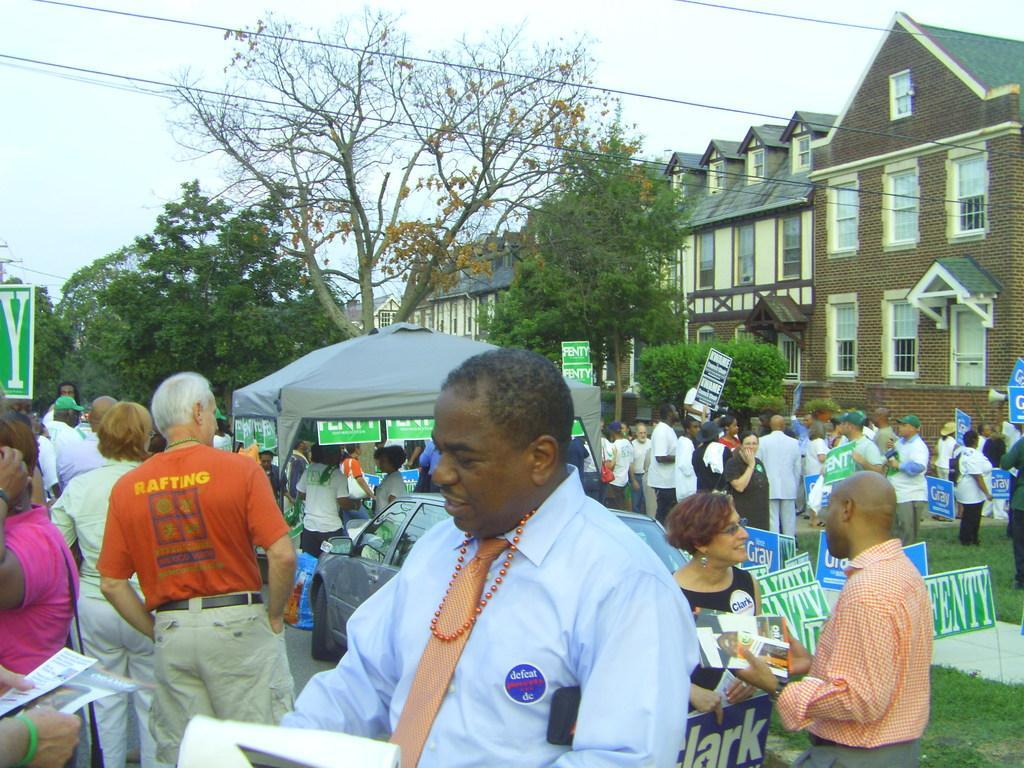Could you give a brief overview of what you see in this image? This image is taken outdoors. At the top of the image there is the sky. In the background there are a few buildings with walls, windows, doors and roofs. There are a few trees and plants. Many people are standing on the ground and a few are holding boards in their hands. There are many boards with text on them. There is a tent. A car is parked on the road. In the middle a few people are standing on the road and holding papers and books in their hands. 